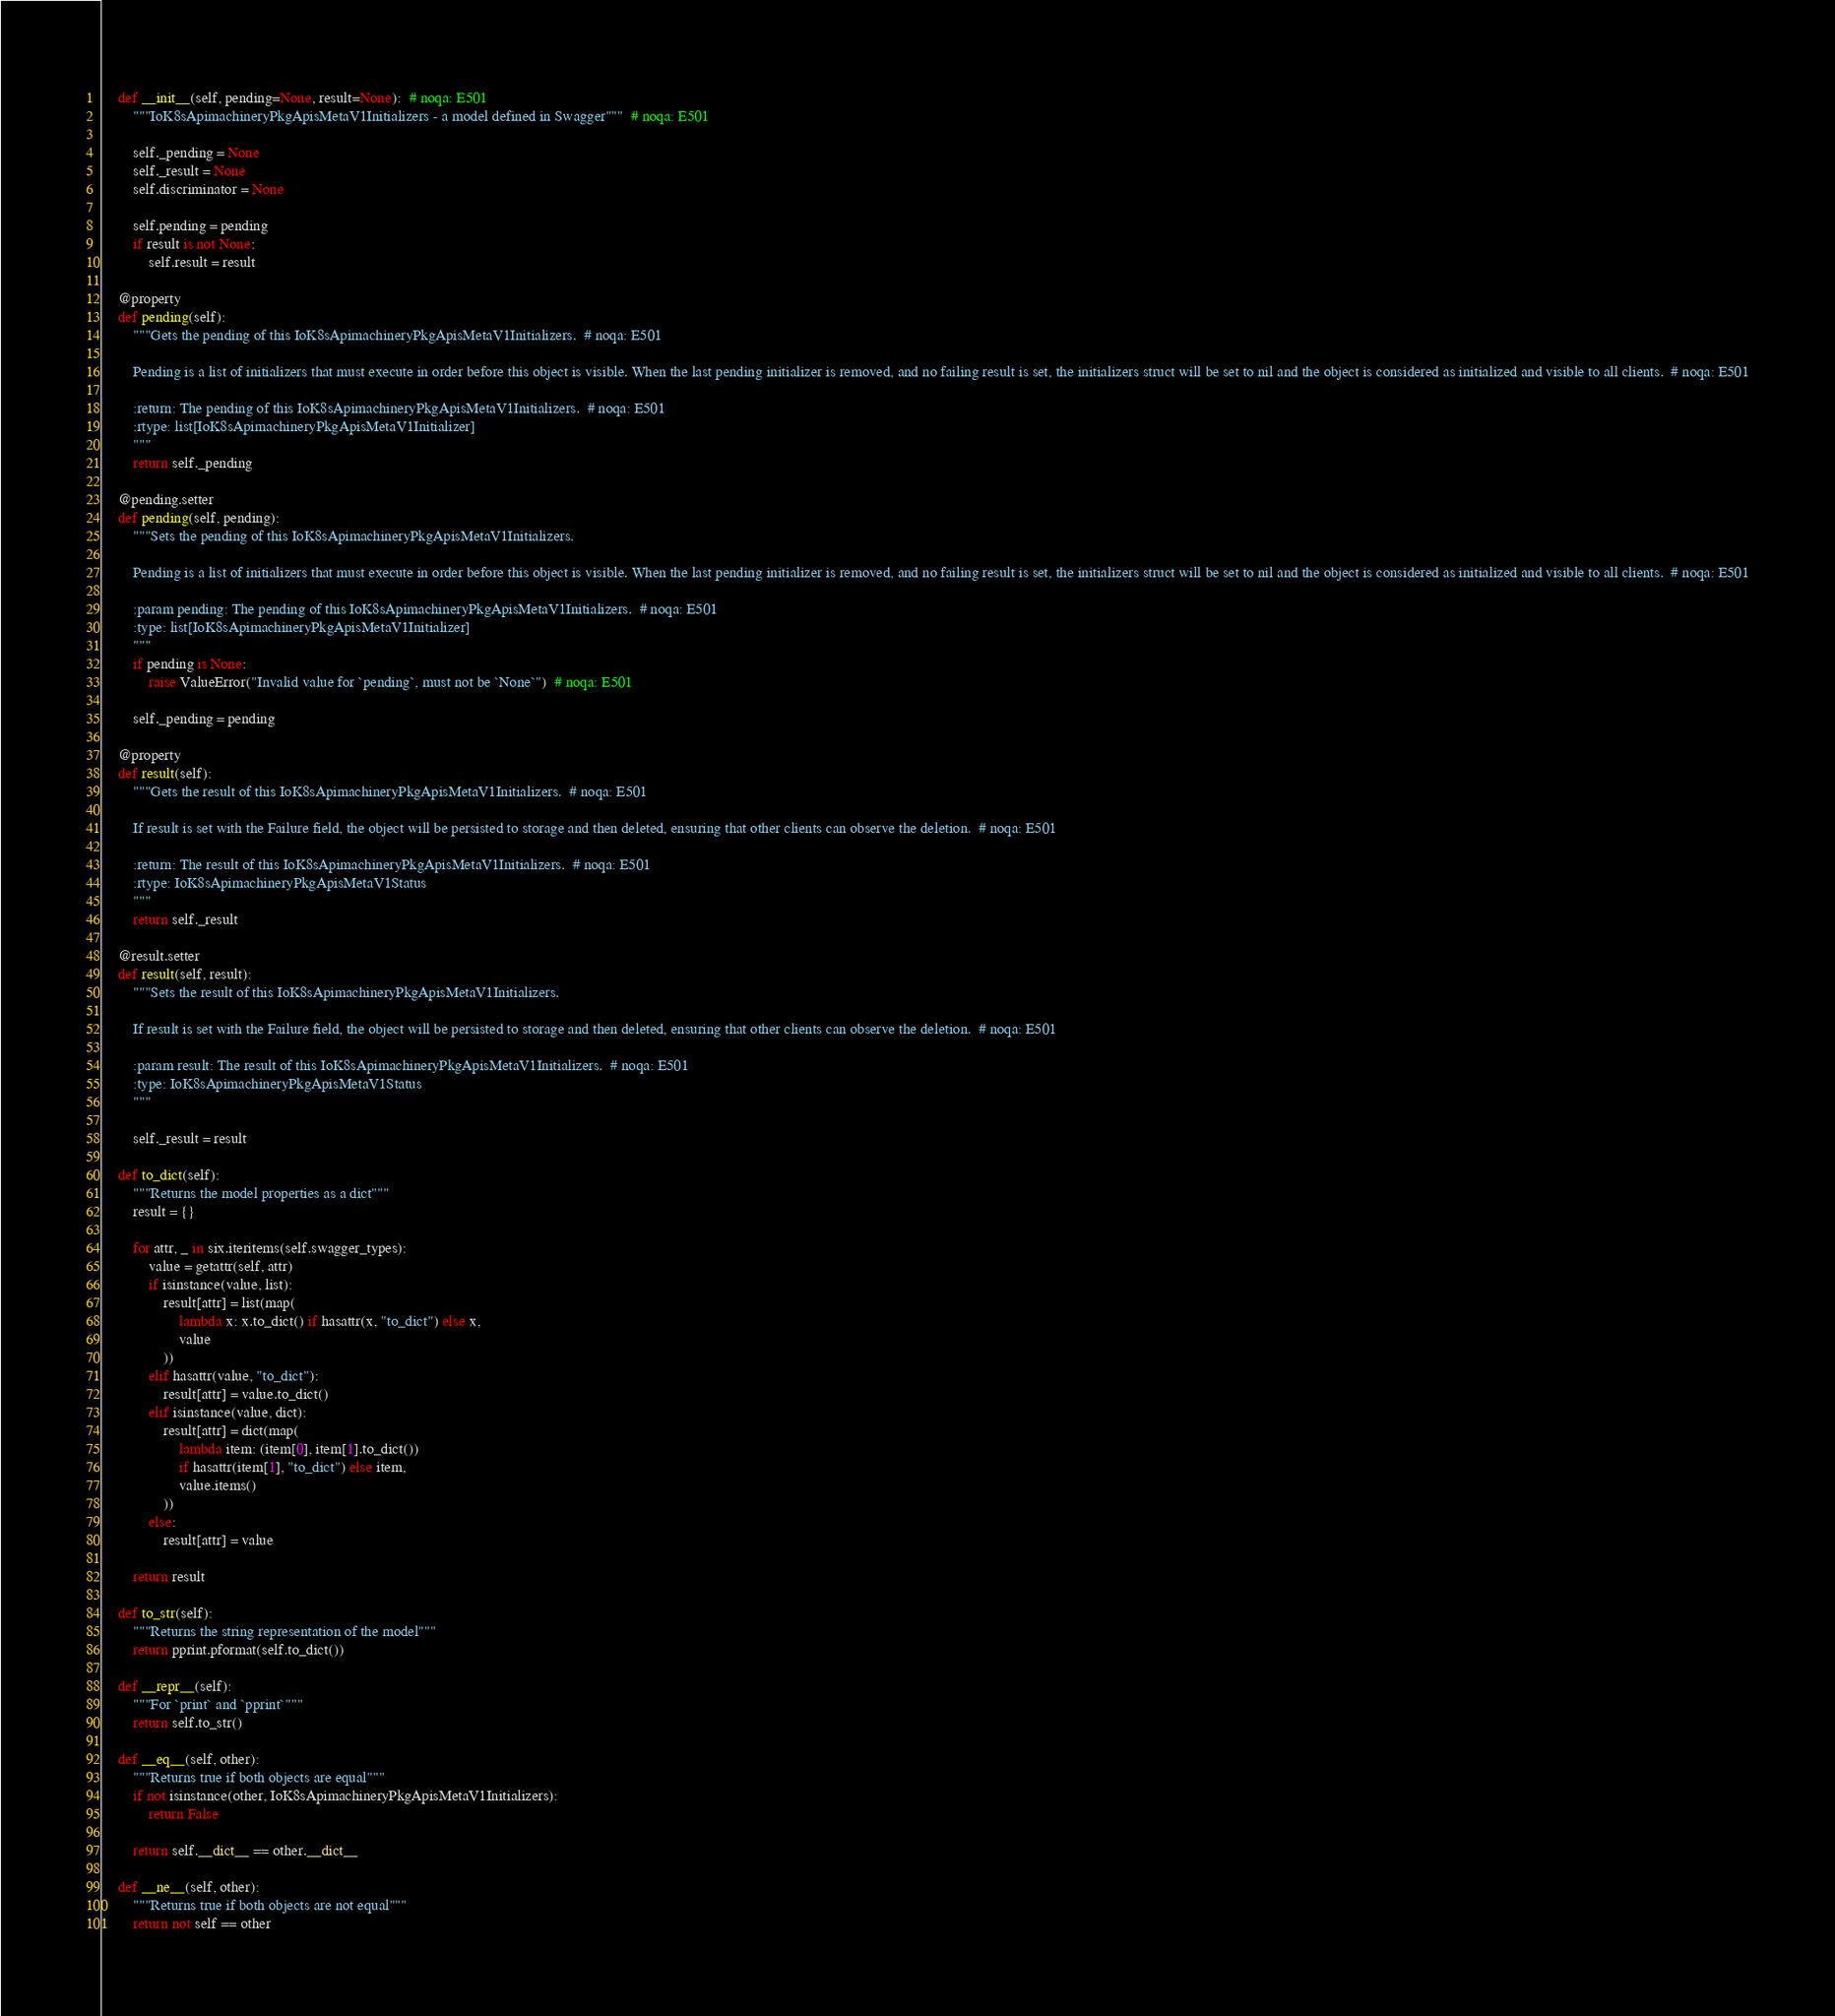Convert code to text. <code><loc_0><loc_0><loc_500><loc_500><_Python_>
    def __init__(self, pending=None, result=None):  # noqa: E501
        """IoK8sApimachineryPkgApisMetaV1Initializers - a model defined in Swagger"""  # noqa: E501

        self._pending = None
        self._result = None
        self.discriminator = None

        self.pending = pending
        if result is not None:
            self.result = result

    @property
    def pending(self):
        """Gets the pending of this IoK8sApimachineryPkgApisMetaV1Initializers.  # noqa: E501

        Pending is a list of initializers that must execute in order before this object is visible. When the last pending initializer is removed, and no failing result is set, the initializers struct will be set to nil and the object is considered as initialized and visible to all clients.  # noqa: E501

        :return: The pending of this IoK8sApimachineryPkgApisMetaV1Initializers.  # noqa: E501
        :rtype: list[IoK8sApimachineryPkgApisMetaV1Initializer]
        """
        return self._pending

    @pending.setter
    def pending(self, pending):
        """Sets the pending of this IoK8sApimachineryPkgApisMetaV1Initializers.

        Pending is a list of initializers that must execute in order before this object is visible. When the last pending initializer is removed, and no failing result is set, the initializers struct will be set to nil and the object is considered as initialized and visible to all clients.  # noqa: E501

        :param pending: The pending of this IoK8sApimachineryPkgApisMetaV1Initializers.  # noqa: E501
        :type: list[IoK8sApimachineryPkgApisMetaV1Initializer]
        """
        if pending is None:
            raise ValueError("Invalid value for `pending`, must not be `None`")  # noqa: E501

        self._pending = pending

    @property
    def result(self):
        """Gets the result of this IoK8sApimachineryPkgApisMetaV1Initializers.  # noqa: E501

        If result is set with the Failure field, the object will be persisted to storage and then deleted, ensuring that other clients can observe the deletion.  # noqa: E501

        :return: The result of this IoK8sApimachineryPkgApisMetaV1Initializers.  # noqa: E501
        :rtype: IoK8sApimachineryPkgApisMetaV1Status
        """
        return self._result

    @result.setter
    def result(self, result):
        """Sets the result of this IoK8sApimachineryPkgApisMetaV1Initializers.

        If result is set with the Failure field, the object will be persisted to storage and then deleted, ensuring that other clients can observe the deletion.  # noqa: E501

        :param result: The result of this IoK8sApimachineryPkgApisMetaV1Initializers.  # noqa: E501
        :type: IoK8sApimachineryPkgApisMetaV1Status
        """

        self._result = result

    def to_dict(self):
        """Returns the model properties as a dict"""
        result = {}

        for attr, _ in six.iteritems(self.swagger_types):
            value = getattr(self, attr)
            if isinstance(value, list):
                result[attr] = list(map(
                    lambda x: x.to_dict() if hasattr(x, "to_dict") else x,
                    value
                ))
            elif hasattr(value, "to_dict"):
                result[attr] = value.to_dict()
            elif isinstance(value, dict):
                result[attr] = dict(map(
                    lambda item: (item[0], item[1].to_dict())
                    if hasattr(item[1], "to_dict") else item,
                    value.items()
                ))
            else:
                result[attr] = value

        return result

    def to_str(self):
        """Returns the string representation of the model"""
        return pprint.pformat(self.to_dict())

    def __repr__(self):
        """For `print` and `pprint`"""
        return self.to_str()

    def __eq__(self, other):
        """Returns true if both objects are equal"""
        if not isinstance(other, IoK8sApimachineryPkgApisMetaV1Initializers):
            return False

        return self.__dict__ == other.__dict__

    def __ne__(self, other):
        """Returns true if both objects are not equal"""
        return not self == other
</code> 